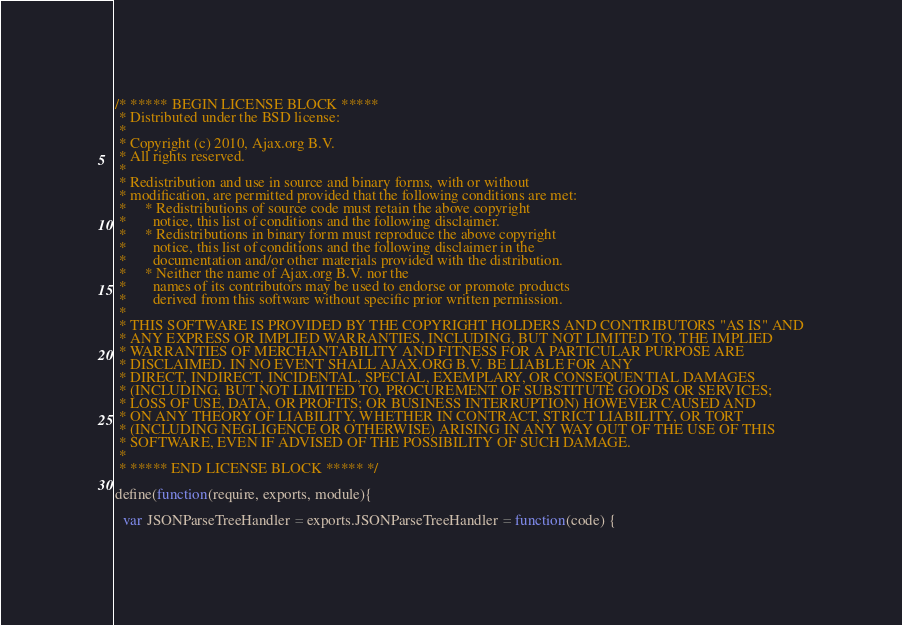<code> <loc_0><loc_0><loc_500><loc_500><_JavaScript_>/* ***** BEGIN LICENSE BLOCK *****
 * Distributed under the BSD license:
 *
 * Copyright (c) 2010, Ajax.org B.V.
 * All rights reserved.
 * 
 * Redistribution and use in source and binary forms, with or without
 * modification, are permitted provided that the following conditions are met:
 *     * Redistributions of source code must retain the above copyright
 *       notice, this list of conditions and the following disclaimer.
 *     * Redistributions in binary form must reproduce the above copyright
 *       notice, this list of conditions and the following disclaimer in the
 *       documentation and/or other materials provided with the distribution.
 *     * Neither the name of Ajax.org B.V. nor the
 *       names of its contributors may be used to endorse or promote products
 *       derived from this software without specific prior written permission.
 * 
 * THIS SOFTWARE IS PROVIDED BY THE COPYRIGHT HOLDERS AND CONTRIBUTORS "AS IS" AND
 * ANY EXPRESS OR IMPLIED WARRANTIES, INCLUDING, BUT NOT LIMITED TO, THE IMPLIED
 * WARRANTIES OF MERCHANTABILITY AND FITNESS FOR A PARTICULAR PURPOSE ARE
 * DISCLAIMED. IN NO EVENT SHALL AJAX.ORG B.V. BE LIABLE FOR ANY
 * DIRECT, INDIRECT, INCIDENTAL, SPECIAL, EXEMPLARY, OR CONSEQUENTIAL DAMAGES
 * (INCLUDING, BUT NOT LIMITED TO, PROCUREMENT OF SUBSTITUTE GOODS OR SERVICES;
 * LOSS OF USE, DATA, OR PROFITS; OR BUSINESS INTERRUPTION) HOWEVER CAUSED AND
 * ON ANY THEORY OF LIABILITY, WHETHER IN CONTRACT, STRICT LIABILITY, OR TORT
 * (INCLUDING NEGLIGENCE OR OTHERWISE) ARISING IN ANY WAY OUT OF THE USE OF THIS
 * SOFTWARE, EVEN IF ADVISED OF THE POSSIBILITY OF SUCH DAMAGE.
 *
 * ***** END LICENSE BLOCK ***** */
 
define(function(require, exports, module){

  var JSONParseTreeHandler = exports.JSONParseTreeHandler = function(code) {
</code> 